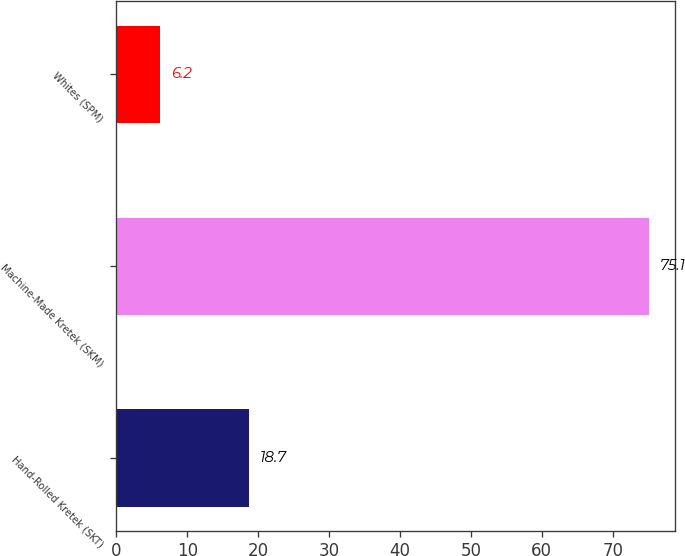<chart> <loc_0><loc_0><loc_500><loc_500><bar_chart><fcel>Hand-Rolled Kretek (SKT)<fcel>Machine-Made Kretek (SKM)<fcel>Whites (SPM)<nl><fcel>18.7<fcel>75.1<fcel>6.2<nl></chart> 